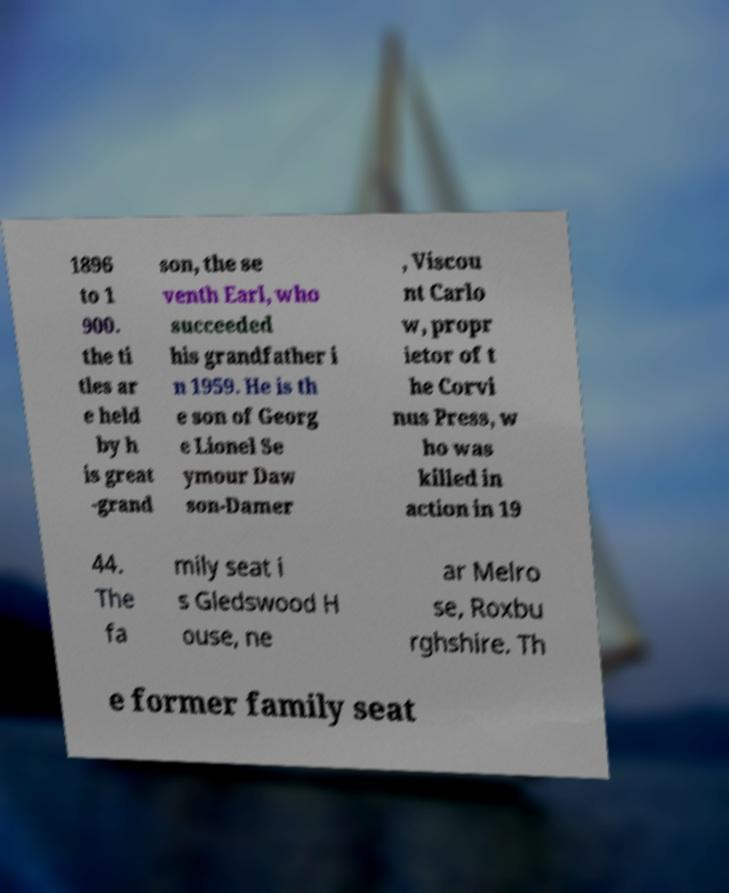Could you extract and type out the text from this image? 1896 to 1 900. the ti tles ar e held by h is great -grand son, the se venth Earl, who succeeded his grandfather i n 1959. He is th e son of Georg e Lionel Se ymour Daw son-Damer , Viscou nt Carlo w, propr ietor of t he Corvi nus Press, w ho was killed in action in 19 44. The fa mily seat i s Gledswood H ouse, ne ar Melro se, Roxbu rghshire. Th e former family seat 